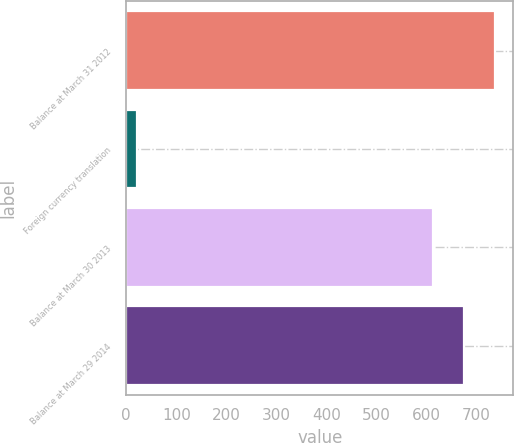Convert chart to OTSL. <chart><loc_0><loc_0><loc_500><loc_500><bar_chart><fcel>Balance at March 31 2012<fcel>Foreign currency translation<fcel>Balance at March 30 2013<fcel>Balance at March 29 2014<nl><fcel>736.8<fcel>21<fcel>614<fcel>675.4<nl></chart> 